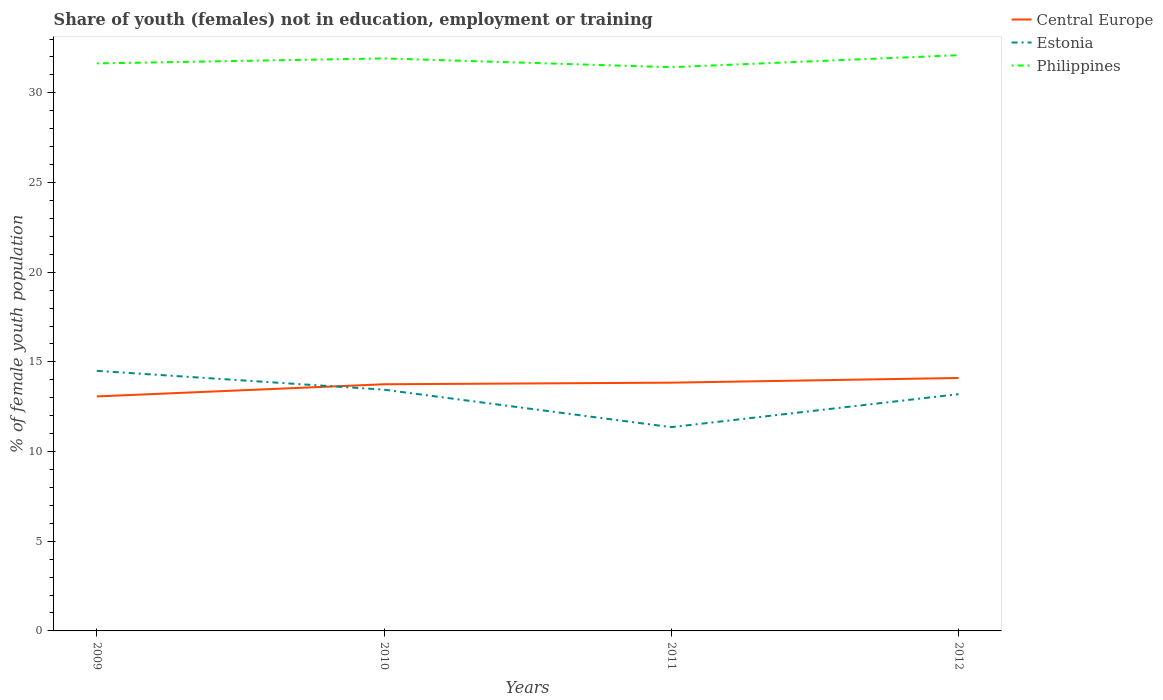Does the line corresponding to Estonia intersect with the line corresponding to Central Europe?
Keep it short and to the point. Yes. Across all years, what is the maximum percentage of unemployed female population in in Central Europe?
Your response must be concise. 13.07. What is the total percentage of unemployed female population in in Central Europe in the graph?
Offer a very short reply. -0.09. What is the difference between the highest and the second highest percentage of unemployed female population in in Estonia?
Provide a short and direct response. 3.14. What is the difference between the highest and the lowest percentage of unemployed female population in in Philippines?
Your answer should be very brief. 2. Is the percentage of unemployed female population in in Central Europe strictly greater than the percentage of unemployed female population in in Philippines over the years?
Give a very brief answer. Yes. Are the values on the major ticks of Y-axis written in scientific E-notation?
Your answer should be very brief. No. Does the graph contain any zero values?
Ensure brevity in your answer.  No. Where does the legend appear in the graph?
Offer a very short reply. Top right. How many legend labels are there?
Offer a very short reply. 3. What is the title of the graph?
Provide a succinct answer. Share of youth (females) not in education, employment or training. Does "Guinea" appear as one of the legend labels in the graph?
Your response must be concise. No. What is the label or title of the Y-axis?
Give a very brief answer. % of female youth population. What is the % of female youth population in Central Europe in 2009?
Ensure brevity in your answer.  13.07. What is the % of female youth population in Estonia in 2009?
Offer a very short reply. 14.5. What is the % of female youth population of Philippines in 2009?
Ensure brevity in your answer.  31.64. What is the % of female youth population in Central Europe in 2010?
Offer a terse response. 13.75. What is the % of female youth population in Estonia in 2010?
Offer a very short reply. 13.45. What is the % of female youth population of Philippines in 2010?
Keep it short and to the point. 31.92. What is the % of female youth population of Central Europe in 2011?
Your answer should be compact. 13.84. What is the % of female youth population of Estonia in 2011?
Offer a terse response. 11.36. What is the % of female youth population in Philippines in 2011?
Your answer should be very brief. 31.43. What is the % of female youth population of Central Europe in 2012?
Provide a succinct answer. 14.1. What is the % of female youth population in Estonia in 2012?
Ensure brevity in your answer.  13.2. What is the % of female youth population of Philippines in 2012?
Your answer should be compact. 32.1. Across all years, what is the maximum % of female youth population in Central Europe?
Offer a very short reply. 14.1. Across all years, what is the maximum % of female youth population in Estonia?
Your answer should be compact. 14.5. Across all years, what is the maximum % of female youth population in Philippines?
Make the answer very short. 32.1. Across all years, what is the minimum % of female youth population of Central Europe?
Provide a short and direct response. 13.07. Across all years, what is the minimum % of female youth population in Estonia?
Give a very brief answer. 11.36. Across all years, what is the minimum % of female youth population in Philippines?
Make the answer very short. 31.43. What is the total % of female youth population in Central Europe in the graph?
Your answer should be very brief. 54.77. What is the total % of female youth population of Estonia in the graph?
Provide a succinct answer. 52.51. What is the total % of female youth population in Philippines in the graph?
Offer a very short reply. 127.09. What is the difference between the % of female youth population of Central Europe in 2009 and that in 2010?
Your response must be concise. -0.68. What is the difference between the % of female youth population in Estonia in 2009 and that in 2010?
Provide a succinct answer. 1.05. What is the difference between the % of female youth population in Philippines in 2009 and that in 2010?
Provide a succinct answer. -0.28. What is the difference between the % of female youth population of Central Europe in 2009 and that in 2011?
Make the answer very short. -0.77. What is the difference between the % of female youth population of Estonia in 2009 and that in 2011?
Ensure brevity in your answer.  3.14. What is the difference between the % of female youth population of Philippines in 2009 and that in 2011?
Your response must be concise. 0.21. What is the difference between the % of female youth population of Central Europe in 2009 and that in 2012?
Provide a succinct answer. -1.03. What is the difference between the % of female youth population in Estonia in 2009 and that in 2012?
Provide a succinct answer. 1.3. What is the difference between the % of female youth population of Philippines in 2009 and that in 2012?
Ensure brevity in your answer.  -0.46. What is the difference between the % of female youth population in Central Europe in 2010 and that in 2011?
Provide a short and direct response. -0.09. What is the difference between the % of female youth population of Estonia in 2010 and that in 2011?
Your answer should be very brief. 2.09. What is the difference between the % of female youth population of Philippines in 2010 and that in 2011?
Your response must be concise. 0.49. What is the difference between the % of female youth population of Central Europe in 2010 and that in 2012?
Keep it short and to the point. -0.35. What is the difference between the % of female youth population of Philippines in 2010 and that in 2012?
Offer a very short reply. -0.18. What is the difference between the % of female youth population of Central Europe in 2011 and that in 2012?
Provide a succinct answer. -0.26. What is the difference between the % of female youth population of Estonia in 2011 and that in 2012?
Give a very brief answer. -1.84. What is the difference between the % of female youth population of Philippines in 2011 and that in 2012?
Keep it short and to the point. -0.67. What is the difference between the % of female youth population in Central Europe in 2009 and the % of female youth population in Estonia in 2010?
Keep it short and to the point. -0.38. What is the difference between the % of female youth population in Central Europe in 2009 and the % of female youth population in Philippines in 2010?
Provide a succinct answer. -18.85. What is the difference between the % of female youth population in Estonia in 2009 and the % of female youth population in Philippines in 2010?
Make the answer very short. -17.42. What is the difference between the % of female youth population in Central Europe in 2009 and the % of female youth population in Estonia in 2011?
Your response must be concise. 1.71. What is the difference between the % of female youth population of Central Europe in 2009 and the % of female youth population of Philippines in 2011?
Make the answer very short. -18.36. What is the difference between the % of female youth population in Estonia in 2009 and the % of female youth population in Philippines in 2011?
Offer a very short reply. -16.93. What is the difference between the % of female youth population of Central Europe in 2009 and the % of female youth population of Estonia in 2012?
Ensure brevity in your answer.  -0.13. What is the difference between the % of female youth population of Central Europe in 2009 and the % of female youth population of Philippines in 2012?
Provide a succinct answer. -19.03. What is the difference between the % of female youth population of Estonia in 2009 and the % of female youth population of Philippines in 2012?
Your answer should be compact. -17.6. What is the difference between the % of female youth population of Central Europe in 2010 and the % of female youth population of Estonia in 2011?
Give a very brief answer. 2.39. What is the difference between the % of female youth population in Central Europe in 2010 and the % of female youth population in Philippines in 2011?
Offer a terse response. -17.68. What is the difference between the % of female youth population in Estonia in 2010 and the % of female youth population in Philippines in 2011?
Your answer should be very brief. -17.98. What is the difference between the % of female youth population in Central Europe in 2010 and the % of female youth population in Estonia in 2012?
Make the answer very short. 0.55. What is the difference between the % of female youth population of Central Europe in 2010 and the % of female youth population of Philippines in 2012?
Your answer should be very brief. -18.35. What is the difference between the % of female youth population in Estonia in 2010 and the % of female youth population in Philippines in 2012?
Your answer should be compact. -18.65. What is the difference between the % of female youth population in Central Europe in 2011 and the % of female youth population in Estonia in 2012?
Provide a short and direct response. 0.64. What is the difference between the % of female youth population in Central Europe in 2011 and the % of female youth population in Philippines in 2012?
Your answer should be very brief. -18.26. What is the difference between the % of female youth population in Estonia in 2011 and the % of female youth population in Philippines in 2012?
Your answer should be very brief. -20.74. What is the average % of female youth population in Central Europe per year?
Keep it short and to the point. 13.69. What is the average % of female youth population in Estonia per year?
Ensure brevity in your answer.  13.13. What is the average % of female youth population of Philippines per year?
Ensure brevity in your answer.  31.77. In the year 2009, what is the difference between the % of female youth population of Central Europe and % of female youth population of Estonia?
Offer a terse response. -1.43. In the year 2009, what is the difference between the % of female youth population in Central Europe and % of female youth population in Philippines?
Offer a very short reply. -18.57. In the year 2009, what is the difference between the % of female youth population in Estonia and % of female youth population in Philippines?
Make the answer very short. -17.14. In the year 2010, what is the difference between the % of female youth population in Central Europe and % of female youth population in Estonia?
Make the answer very short. 0.3. In the year 2010, what is the difference between the % of female youth population in Central Europe and % of female youth population in Philippines?
Your answer should be very brief. -18.17. In the year 2010, what is the difference between the % of female youth population in Estonia and % of female youth population in Philippines?
Your answer should be compact. -18.47. In the year 2011, what is the difference between the % of female youth population in Central Europe and % of female youth population in Estonia?
Keep it short and to the point. 2.48. In the year 2011, what is the difference between the % of female youth population in Central Europe and % of female youth population in Philippines?
Provide a short and direct response. -17.59. In the year 2011, what is the difference between the % of female youth population in Estonia and % of female youth population in Philippines?
Offer a very short reply. -20.07. In the year 2012, what is the difference between the % of female youth population of Central Europe and % of female youth population of Estonia?
Your answer should be compact. 0.9. In the year 2012, what is the difference between the % of female youth population of Central Europe and % of female youth population of Philippines?
Ensure brevity in your answer.  -18. In the year 2012, what is the difference between the % of female youth population of Estonia and % of female youth population of Philippines?
Give a very brief answer. -18.9. What is the ratio of the % of female youth population in Central Europe in 2009 to that in 2010?
Provide a short and direct response. 0.95. What is the ratio of the % of female youth population of Estonia in 2009 to that in 2010?
Offer a very short reply. 1.08. What is the ratio of the % of female youth population of Philippines in 2009 to that in 2010?
Ensure brevity in your answer.  0.99. What is the ratio of the % of female youth population of Central Europe in 2009 to that in 2011?
Make the answer very short. 0.94. What is the ratio of the % of female youth population of Estonia in 2009 to that in 2011?
Provide a succinct answer. 1.28. What is the ratio of the % of female youth population in Central Europe in 2009 to that in 2012?
Provide a succinct answer. 0.93. What is the ratio of the % of female youth population of Estonia in 2009 to that in 2012?
Your answer should be compact. 1.1. What is the ratio of the % of female youth population of Philippines in 2009 to that in 2012?
Give a very brief answer. 0.99. What is the ratio of the % of female youth population of Central Europe in 2010 to that in 2011?
Offer a very short reply. 0.99. What is the ratio of the % of female youth population in Estonia in 2010 to that in 2011?
Make the answer very short. 1.18. What is the ratio of the % of female youth population of Philippines in 2010 to that in 2011?
Offer a very short reply. 1.02. What is the ratio of the % of female youth population of Central Europe in 2010 to that in 2012?
Offer a very short reply. 0.98. What is the ratio of the % of female youth population in Estonia in 2010 to that in 2012?
Provide a short and direct response. 1.02. What is the ratio of the % of female youth population in Central Europe in 2011 to that in 2012?
Your response must be concise. 0.98. What is the ratio of the % of female youth population of Estonia in 2011 to that in 2012?
Your response must be concise. 0.86. What is the ratio of the % of female youth population of Philippines in 2011 to that in 2012?
Provide a succinct answer. 0.98. What is the difference between the highest and the second highest % of female youth population in Central Europe?
Ensure brevity in your answer.  0.26. What is the difference between the highest and the second highest % of female youth population of Estonia?
Keep it short and to the point. 1.05. What is the difference between the highest and the second highest % of female youth population in Philippines?
Offer a very short reply. 0.18. What is the difference between the highest and the lowest % of female youth population in Central Europe?
Provide a succinct answer. 1.03. What is the difference between the highest and the lowest % of female youth population of Estonia?
Offer a terse response. 3.14. What is the difference between the highest and the lowest % of female youth population in Philippines?
Make the answer very short. 0.67. 